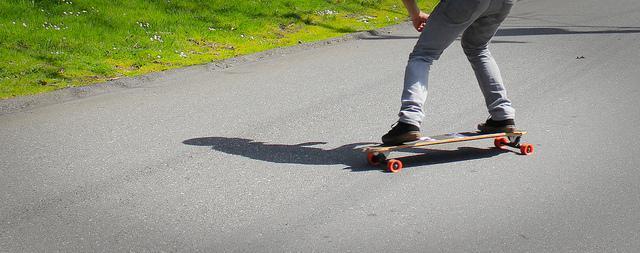How many wheels are on the skateboard?
Give a very brief answer. 4. How many green bottles are on the table?
Give a very brief answer. 0. 